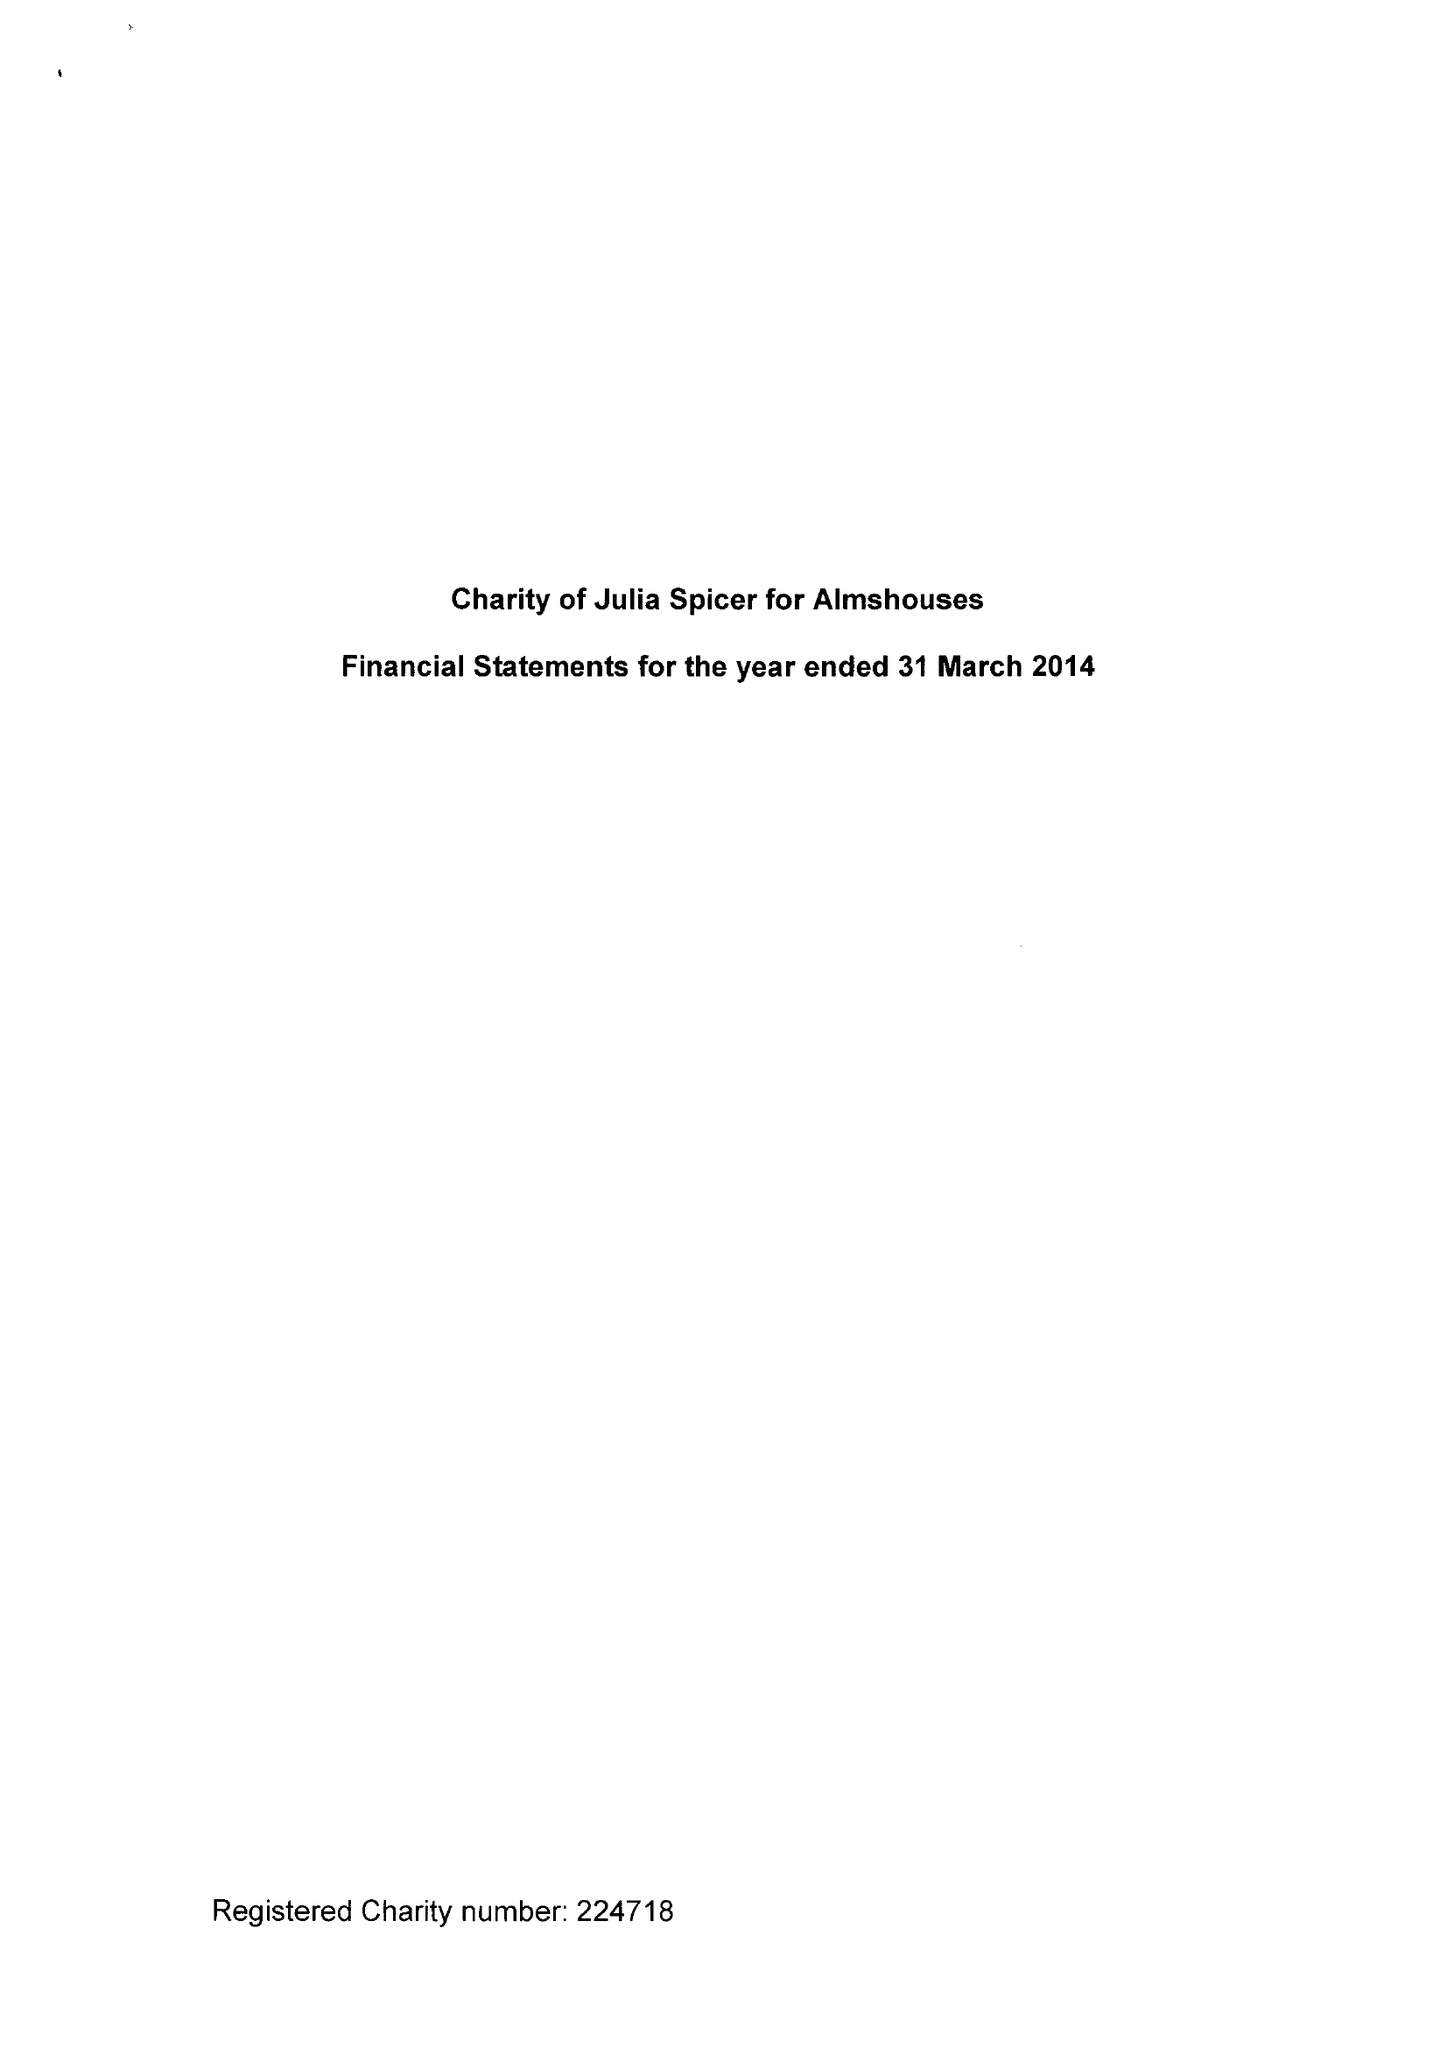What is the value for the income_annually_in_british_pounds?
Answer the question using a single word or phrase. 65087.00 